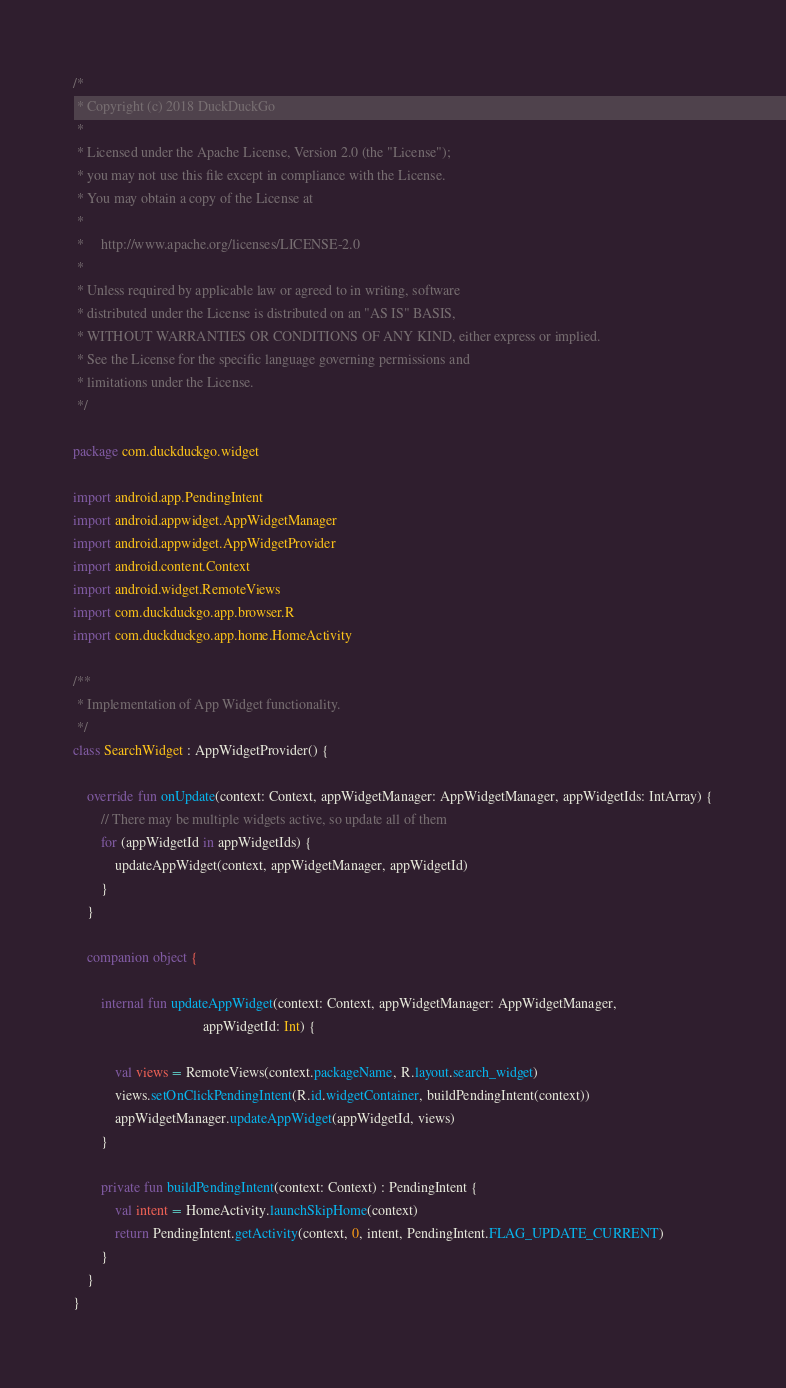Convert code to text. <code><loc_0><loc_0><loc_500><loc_500><_Kotlin_>/*
 * Copyright (c) 2018 DuckDuckGo
 *
 * Licensed under the Apache License, Version 2.0 (the "License");
 * you may not use this file except in compliance with the License.
 * You may obtain a copy of the License at
 *
 *     http://www.apache.org/licenses/LICENSE-2.0
 *
 * Unless required by applicable law or agreed to in writing, software
 * distributed under the License is distributed on an "AS IS" BASIS,
 * WITHOUT WARRANTIES OR CONDITIONS OF ANY KIND, either express or implied.
 * See the License for the specific language governing permissions and
 * limitations under the License.
 */

package com.duckduckgo.widget

import android.app.PendingIntent
import android.appwidget.AppWidgetManager
import android.appwidget.AppWidgetProvider
import android.content.Context
import android.widget.RemoteViews
import com.duckduckgo.app.browser.R
import com.duckduckgo.app.home.HomeActivity

/**
 * Implementation of App Widget functionality.
 */
class SearchWidget : AppWidgetProvider() {

    override fun onUpdate(context: Context, appWidgetManager: AppWidgetManager, appWidgetIds: IntArray) {
        // There may be multiple widgets active, so update all of them
        for (appWidgetId in appWidgetIds) {
            updateAppWidget(context, appWidgetManager, appWidgetId)
        }
    }

    companion object {

        internal fun updateAppWidget(context: Context, appWidgetManager: AppWidgetManager,
                                     appWidgetId: Int) {

            val views = RemoteViews(context.packageName, R.layout.search_widget)
            views.setOnClickPendingIntent(R.id.widgetContainer, buildPendingIntent(context))
            appWidgetManager.updateAppWidget(appWidgetId, views)
        }

        private fun buildPendingIntent(context: Context) : PendingIntent {
            val intent = HomeActivity.launchSkipHome(context)
            return PendingIntent.getActivity(context, 0, intent, PendingIntent.FLAG_UPDATE_CURRENT)
        }
    }
}

</code> 